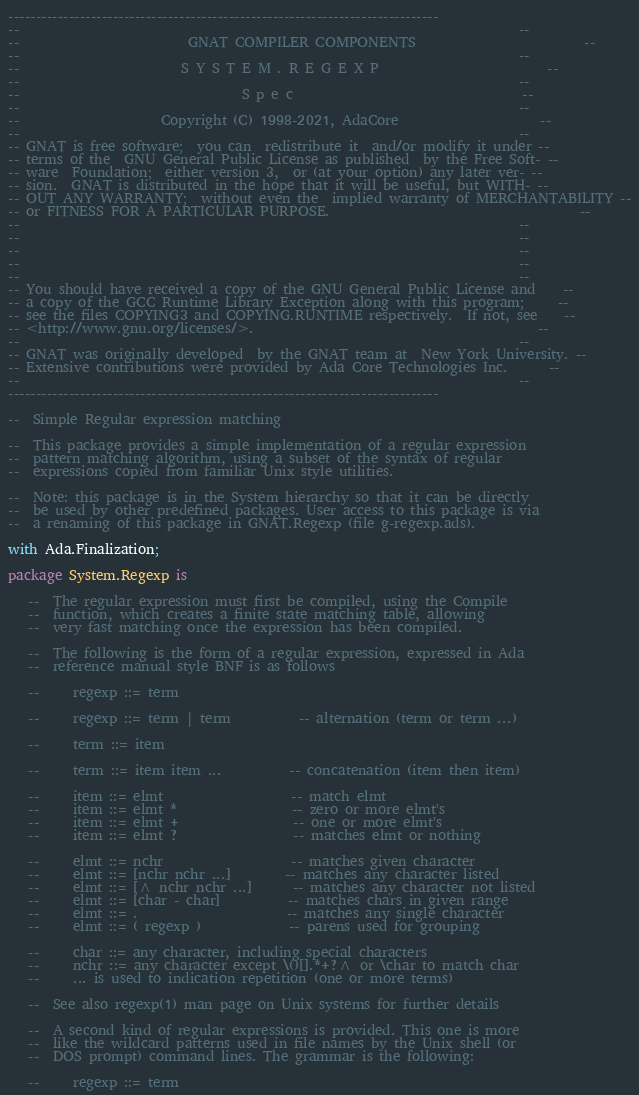Convert code to text. <code><loc_0><loc_0><loc_500><loc_500><_Ada_>------------------------------------------------------------------------------
--                                                                          --
--                         GNAT COMPILER COMPONENTS                         --
--                                                                          --
--                        S Y S T E M . R E G E X P                         --
--                                                                          --
--                                 S p e c                                  --
--                                                                          --
--                     Copyright (C) 1998-2021, AdaCore                     --
--                                                                          --
-- GNAT is free software;  you can  redistribute it  and/or modify it under --
-- terms of the  GNU General Public License as published  by the Free Soft- --
-- ware  Foundation;  either version 3,  or (at your option) any later ver- --
-- sion.  GNAT is distributed in the hope that it will be useful, but WITH- --
-- OUT ANY WARRANTY;  without even the  implied warranty of MERCHANTABILITY --
-- or FITNESS FOR A PARTICULAR PURPOSE.                                     --
--                                                                          --
--                                                                          --
--                                                                          --
--                                                                          --
--                                                                          --
-- You should have received a copy of the GNU General Public License and    --
-- a copy of the GCC Runtime Library Exception along with this program;     --
-- see the files COPYING3 and COPYING.RUNTIME respectively.  If not, see    --
-- <http://www.gnu.org/licenses/>.                                          --
--                                                                          --
-- GNAT was originally developed  by the GNAT team at  New York University. --
-- Extensive contributions were provided by Ada Core Technologies Inc.      --
--                                                                          --
------------------------------------------------------------------------------

--  Simple Regular expression matching

--  This package provides a simple implementation of a regular expression
--  pattern matching algorithm, using a subset of the syntax of regular
--  expressions copied from familiar Unix style utilities.

--  Note: this package is in the System hierarchy so that it can be directly
--  be used by other predefined packages. User access to this package is via
--  a renaming of this package in GNAT.Regexp (file g-regexp.ads).

with Ada.Finalization;

package System.Regexp is

   --  The regular expression must first be compiled, using the Compile
   --  function, which creates a finite state matching table, allowing
   --  very fast matching once the expression has been compiled.

   --  The following is the form of a regular expression, expressed in Ada
   --  reference manual style BNF is as follows

   --     regexp ::= term

   --     regexp ::= term | term          -- alternation (term or term ...)

   --     term ::= item

   --     term ::= item item ...          -- concatenation (item then item)

   --     item ::= elmt                   -- match elmt
   --     item ::= elmt *                 -- zero or more elmt's
   --     item ::= elmt +                 -- one or more elmt's
   --     item ::= elmt ?                 -- matches elmt or nothing

   --     elmt ::= nchr                   -- matches given character
   --     elmt ::= [nchr nchr ...]        -- matches any character listed
   --     elmt ::= [^ nchr nchr ...]      -- matches any character not listed
   --     elmt ::= [char - char]          -- matches chars in given range
   --     elmt ::= .                      -- matches any single character
   --     elmt ::= ( regexp )             -- parens used for grouping

   --     char ::= any character, including special characters
   --     nchr ::= any character except \()[].*+?^ or \char to match char
   --     ... is used to indication repetition (one or more terms)

   --  See also regexp(1) man page on Unix systems for further details

   --  A second kind of regular expressions is provided. This one is more
   --  like the wildcard patterns used in file names by the Unix shell (or
   --  DOS prompt) command lines. The grammar is the following:

   --     regexp ::= term
</code> 